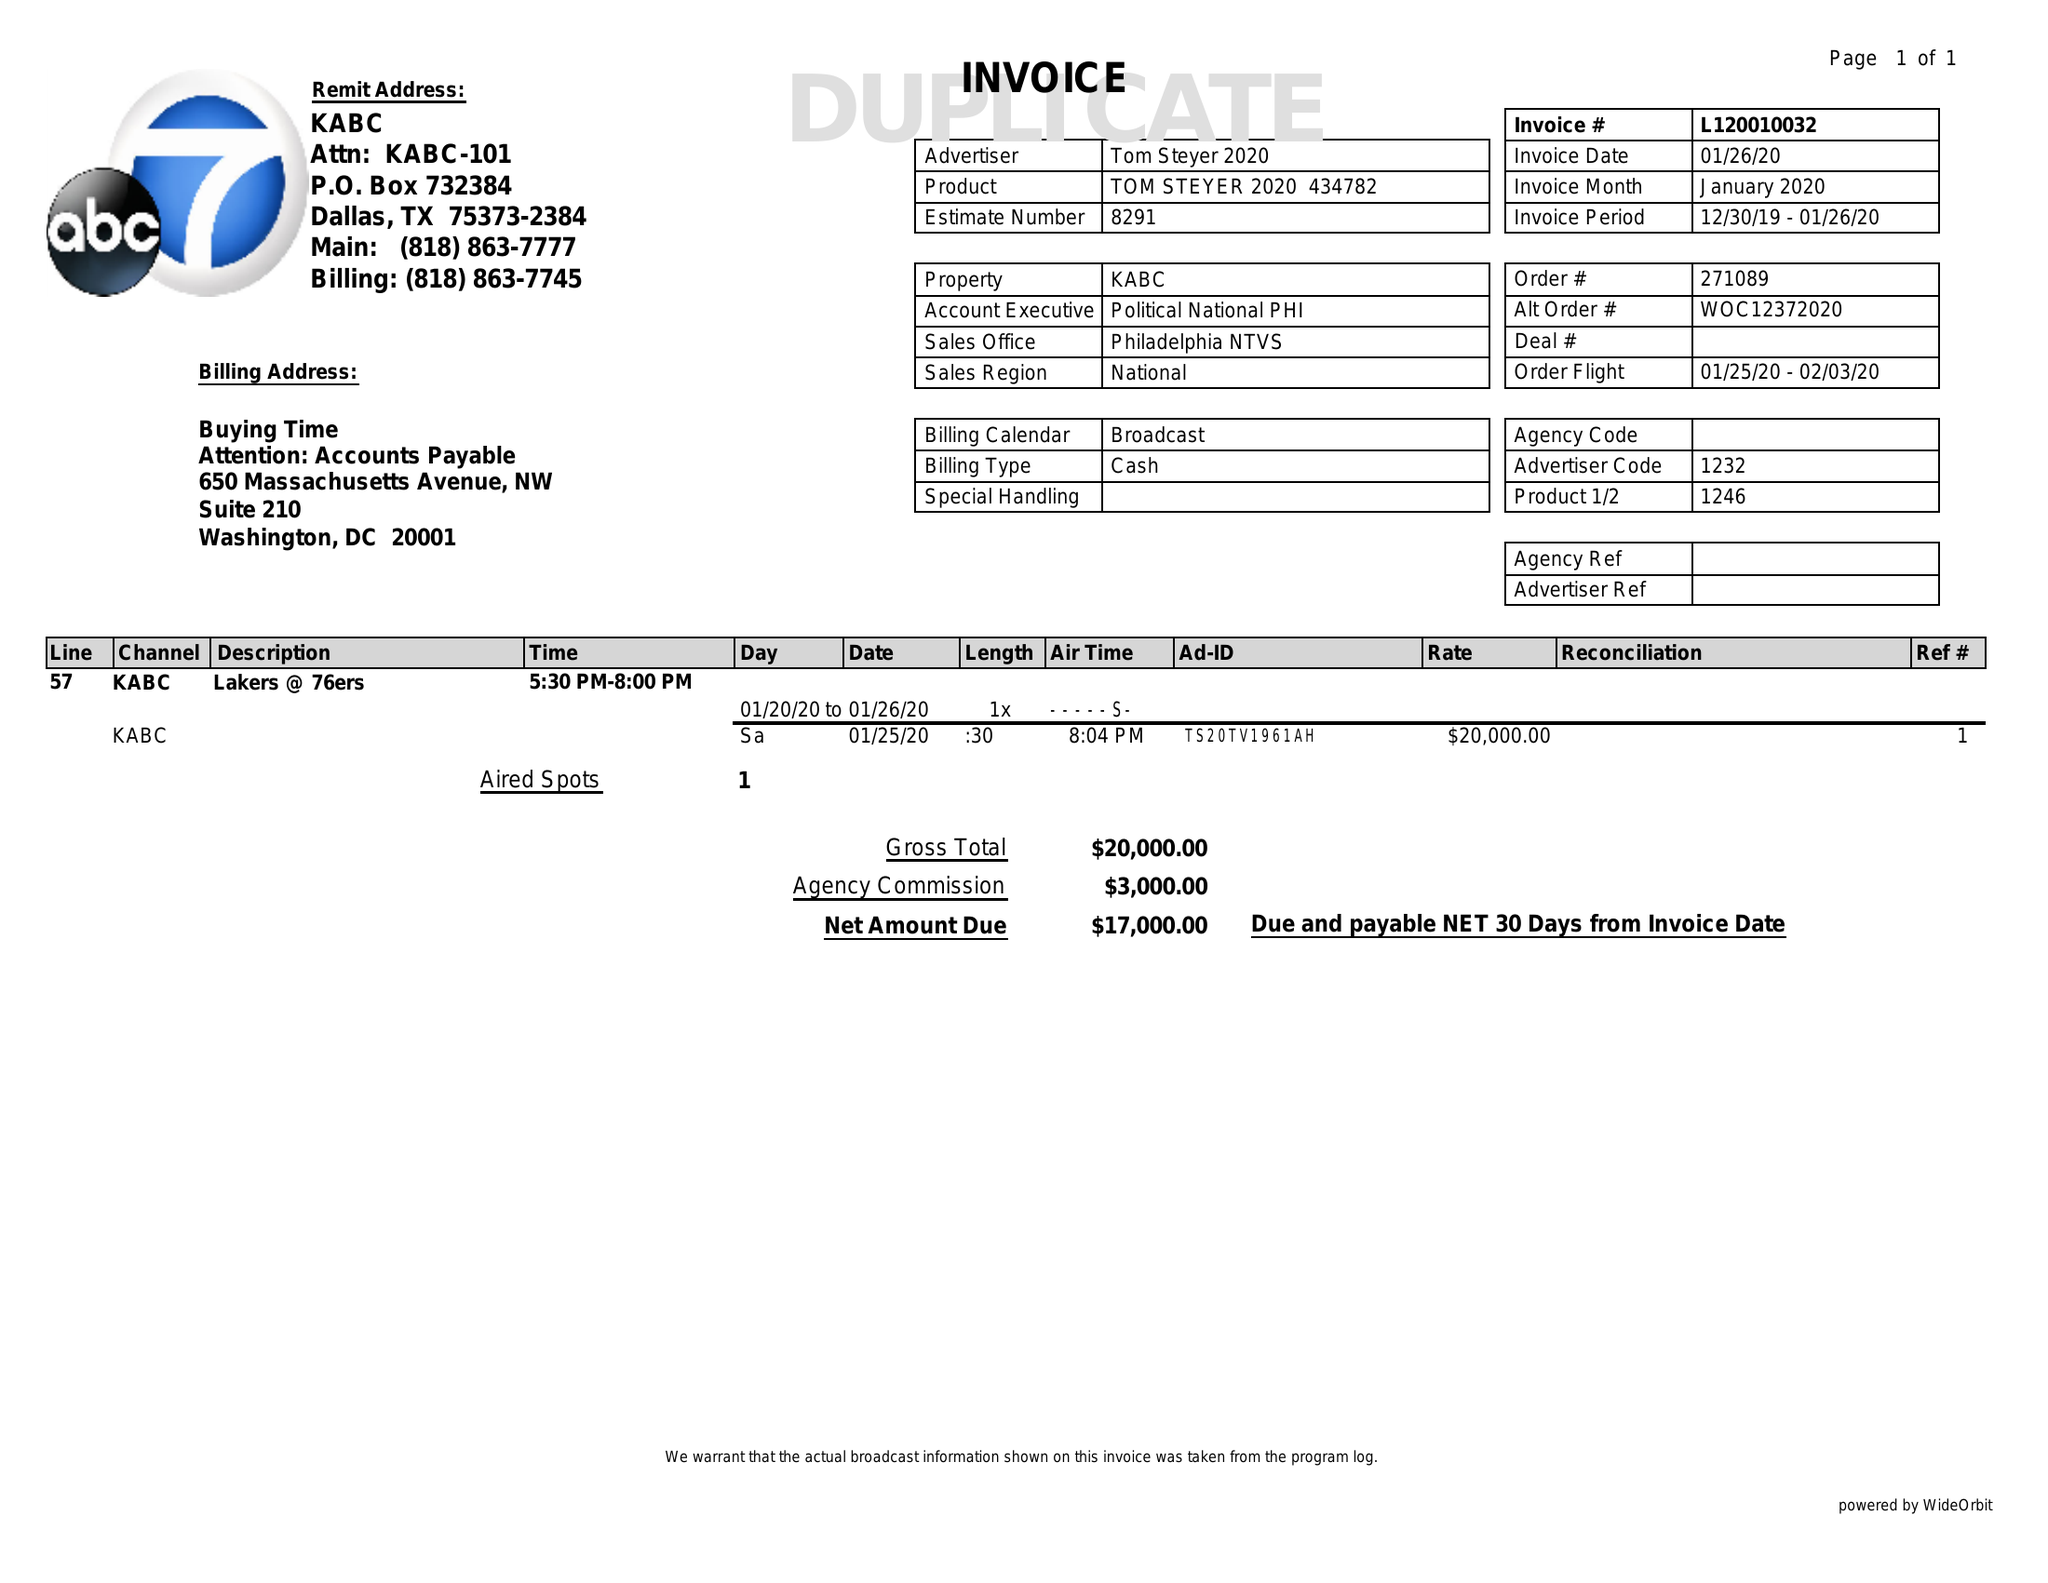What is the value for the flight_to?
Answer the question using a single word or phrase. 02/03/20 